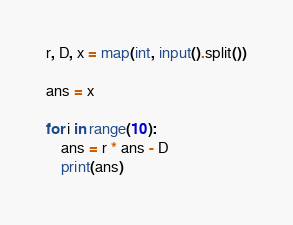<code> <loc_0><loc_0><loc_500><loc_500><_Python_>r, D, x = map(int, input().split())

ans = x

for i in range(10):
    ans = r * ans - D
    print(ans)</code> 